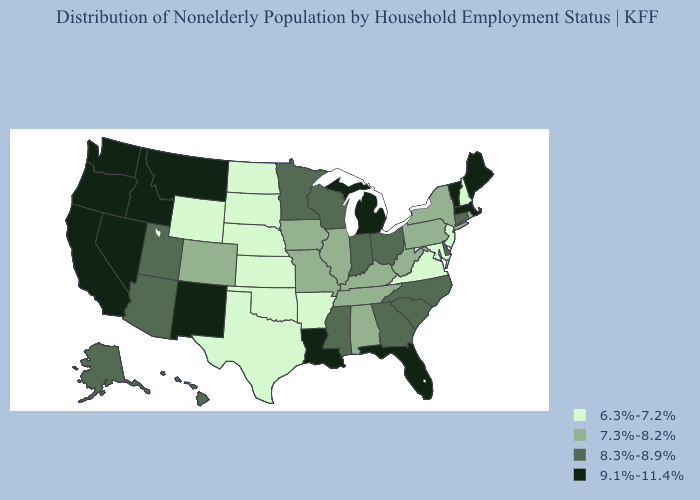What is the value of Louisiana?
Answer briefly. 9.1%-11.4%. Does Oklahoma have the lowest value in the South?
Give a very brief answer. Yes. Which states hav the highest value in the MidWest?
Answer briefly. Michigan. Does Virginia have a lower value than Maryland?
Keep it brief. No. Does Florida have the lowest value in the South?
Short answer required. No. Which states have the highest value in the USA?
Short answer required. California, Florida, Idaho, Louisiana, Maine, Massachusetts, Michigan, Montana, Nevada, New Mexico, Oregon, Vermont, Washington. Does New Jersey have the highest value in the USA?
Write a very short answer. No. Does Nevada have a higher value than Oklahoma?
Keep it brief. Yes. Name the states that have a value in the range 8.3%-8.9%?
Answer briefly. Alaska, Arizona, Connecticut, Delaware, Georgia, Hawaii, Indiana, Minnesota, Mississippi, North Carolina, Ohio, South Carolina, Utah, Wisconsin. What is the value of Connecticut?
Write a very short answer. 8.3%-8.9%. Among the states that border Virginia , does North Carolina have the lowest value?
Give a very brief answer. No. Does the first symbol in the legend represent the smallest category?
Short answer required. Yes. What is the value of Rhode Island?
Short answer required. 7.3%-8.2%. Does Vermont have the highest value in the USA?
Be succinct. Yes. Does North Carolina have a lower value than Montana?
Short answer required. Yes. 